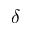Convert formula to latex. <formula><loc_0><loc_0><loc_500><loc_500>\delta</formula> 